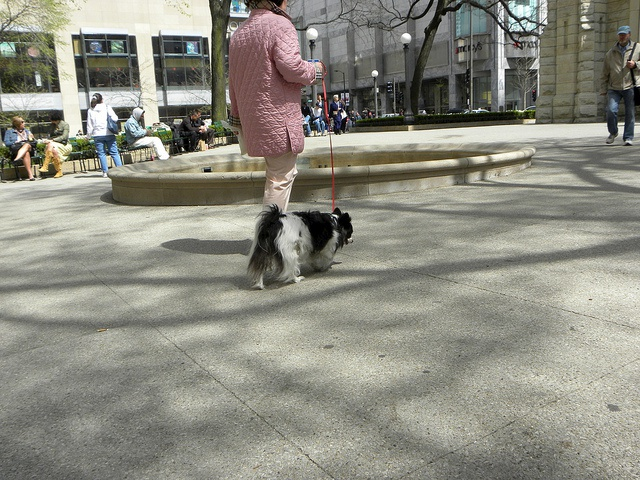Describe the objects in this image and their specific colors. I can see people in beige, brown, gray, darkgray, and lightpink tones, dog in beige, black, gray, darkgray, and lightgray tones, people in beige, black, gray, darkgreen, and darkgray tones, people in beige, white, gray, darkgray, and lightblue tones, and people in beige, black, ivory, khaki, and tan tones in this image. 